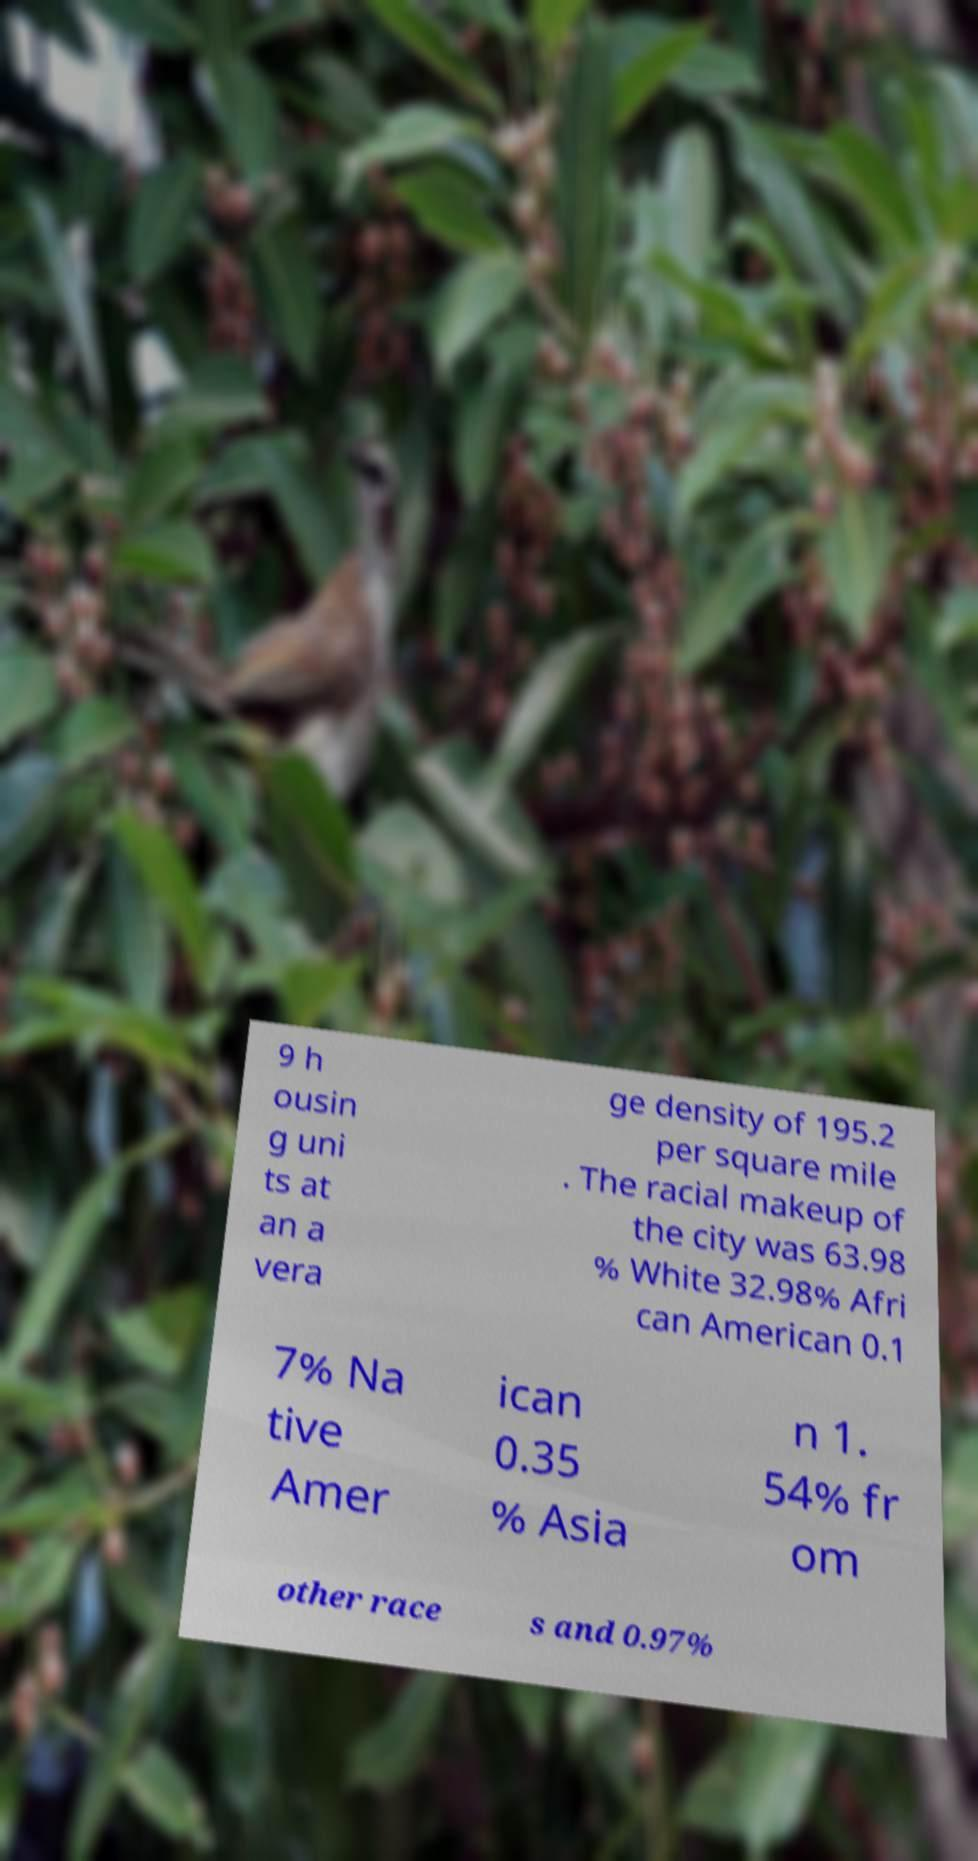Can you read and provide the text displayed in the image?This photo seems to have some interesting text. Can you extract and type it out for me? 9 h ousin g uni ts at an a vera ge density of 195.2 per square mile . The racial makeup of the city was 63.98 % White 32.98% Afri can American 0.1 7% Na tive Amer ican 0.35 % Asia n 1. 54% fr om other race s and 0.97% 